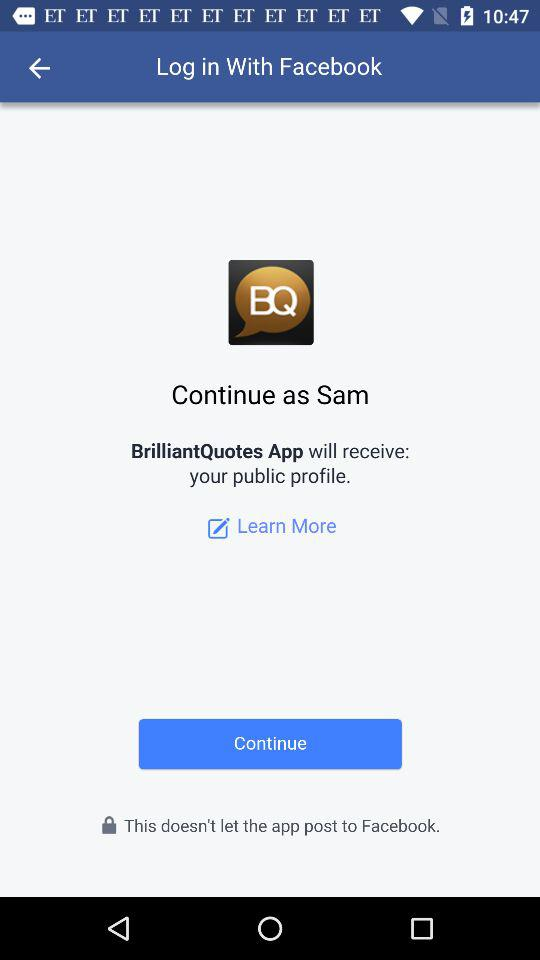What application will receive the public profile? The application is "BrilliantQuotes". 